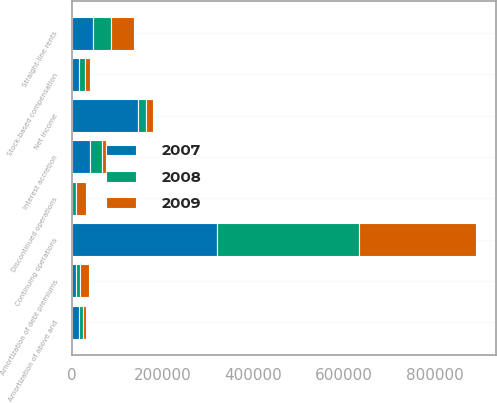Convert chart to OTSL. <chart><loc_0><loc_0><loc_500><loc_500><stacked_bar_chart><ecel><fcel>Net income<fcel>Continuing operations<fcel>Discontinued operations<fcel>Amortization of above and<fcel>Stock-based compensation<fcel>Amortization of debt premiums<fcel>Straight-line rents<fcel>Interest accretion<nl><fcel>2007<fcel>146151<fcel>319583<fcel>542<fcel>14780<fcel>14388<fcel>8328<fcel>46688<fcel>39172<nl><fcel>2008<fcel>16280.5<fcel>313404<fcel>7832<fcel>8440<fcel>13765<fcel>9869<fcel>39463<fcel>27019<nl><fcel>2009<fcel>16280.5<fcel>258264<fcel>22915<fcel>6056<fcel>11408<fcel>17781<fcel>49725<fcel>8739<nl></chart> 